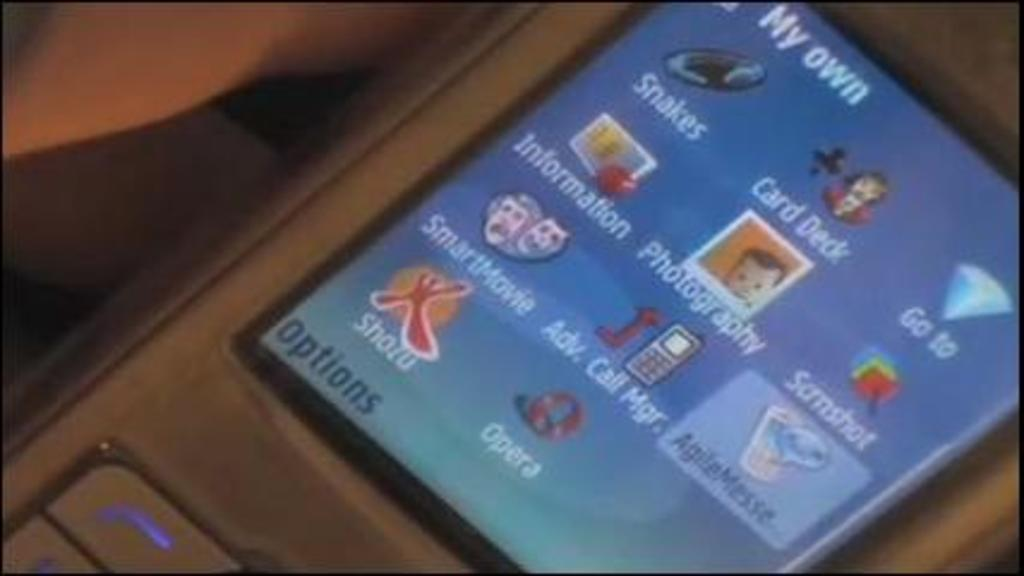<image>
Give a short and clear explanation of the subsequent image. A cell phone says My own and has icons on the screen. 